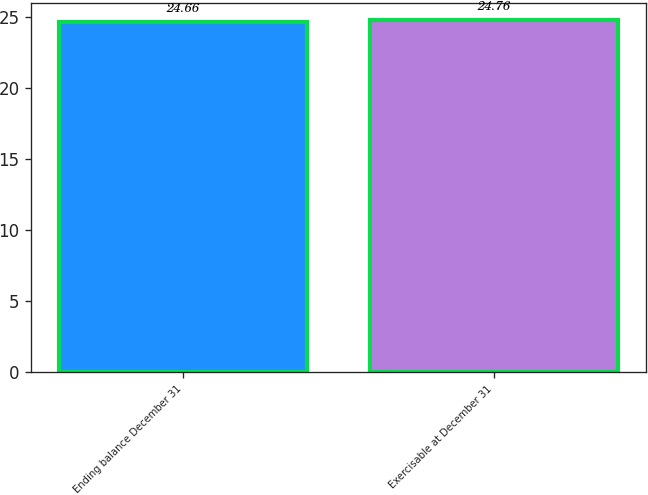<chart> <loc_0><loc_0><loc_500><loc_500><bar_chart><fcel>Ending balance December 31<fcel>Exercisable at December 31<nl><fcel>24.66<fcel>24.76<nl></chart> 